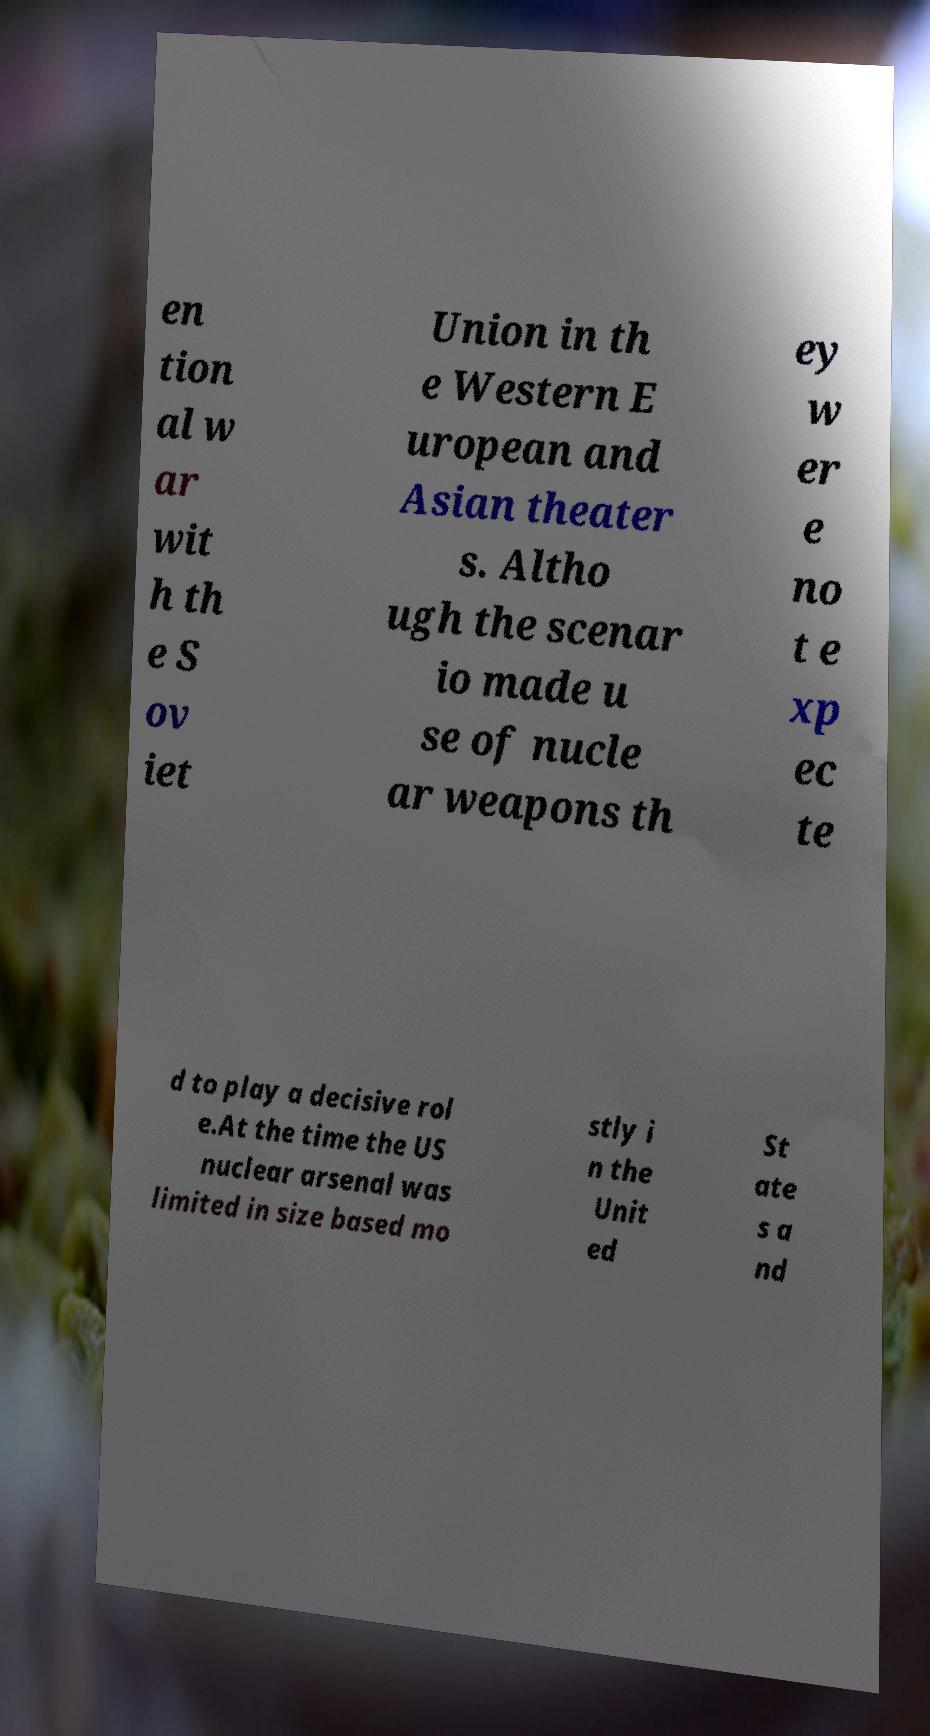Can you read and provide the text displayed in the image?This photo seems to have some interesting text. Can you extract and type it out for me? en tion al w ar wit h th e S ov iet Union in th e Western E uropean and Asian theater s. Altho ugh the scenar io made u se of nucle ar weapons th ey w er e no t e xp ec te d to play a decisive rol e.At the time the US nuclear arsenal was limited in size based mo stly i n the Unit ed St ate s a nd 